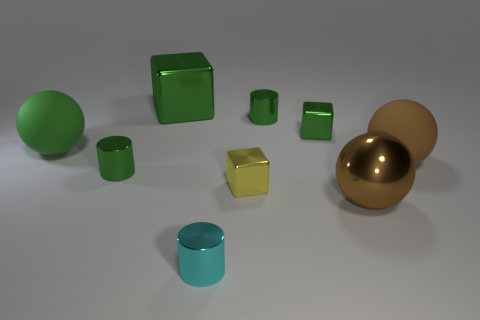Do the big shiny object left of the big brown metallic ball and the yellow metallic thing that is in front of the big green shiny object have the same shape?
Keep it short and to the point. Yes. How many things are tiny cyan objects or green cubes that are to the right of the large green metallic thing?
Offer a very short reply. 2. What material is the cube that is right of the cyan thing and behind the yellow block?
Ensure brevity in your answer.  Metal. What color is the large thing that is the same material as the big green block?
Offer a terse response. Brown. What number of objects are either small yellow metallic objects or tiny metal cylinders?
Ensure brevity in your answer.  4. There is a yellow metallic object; is its size the same as the matte object behind the big brown rubber sphere?
Ensure brevity in your answer.  No. There is a big thing behind the small cylinder that is behind the large rubber thing to the left of the tiny green cube; what color is it?
Your answer should be compact. Green. What color is the large metal ball?
Make the answer very short. Brown. Are there more yellow metal blocks that are behind the big shiny block than big brown rubber things on the left side of the big green sphere?
Your response must be concise. No. There is a cyan shiny thing; is it the same shape as the shiny object that is left of the large green shiny thing?
Your answer should be compact. Yes. 